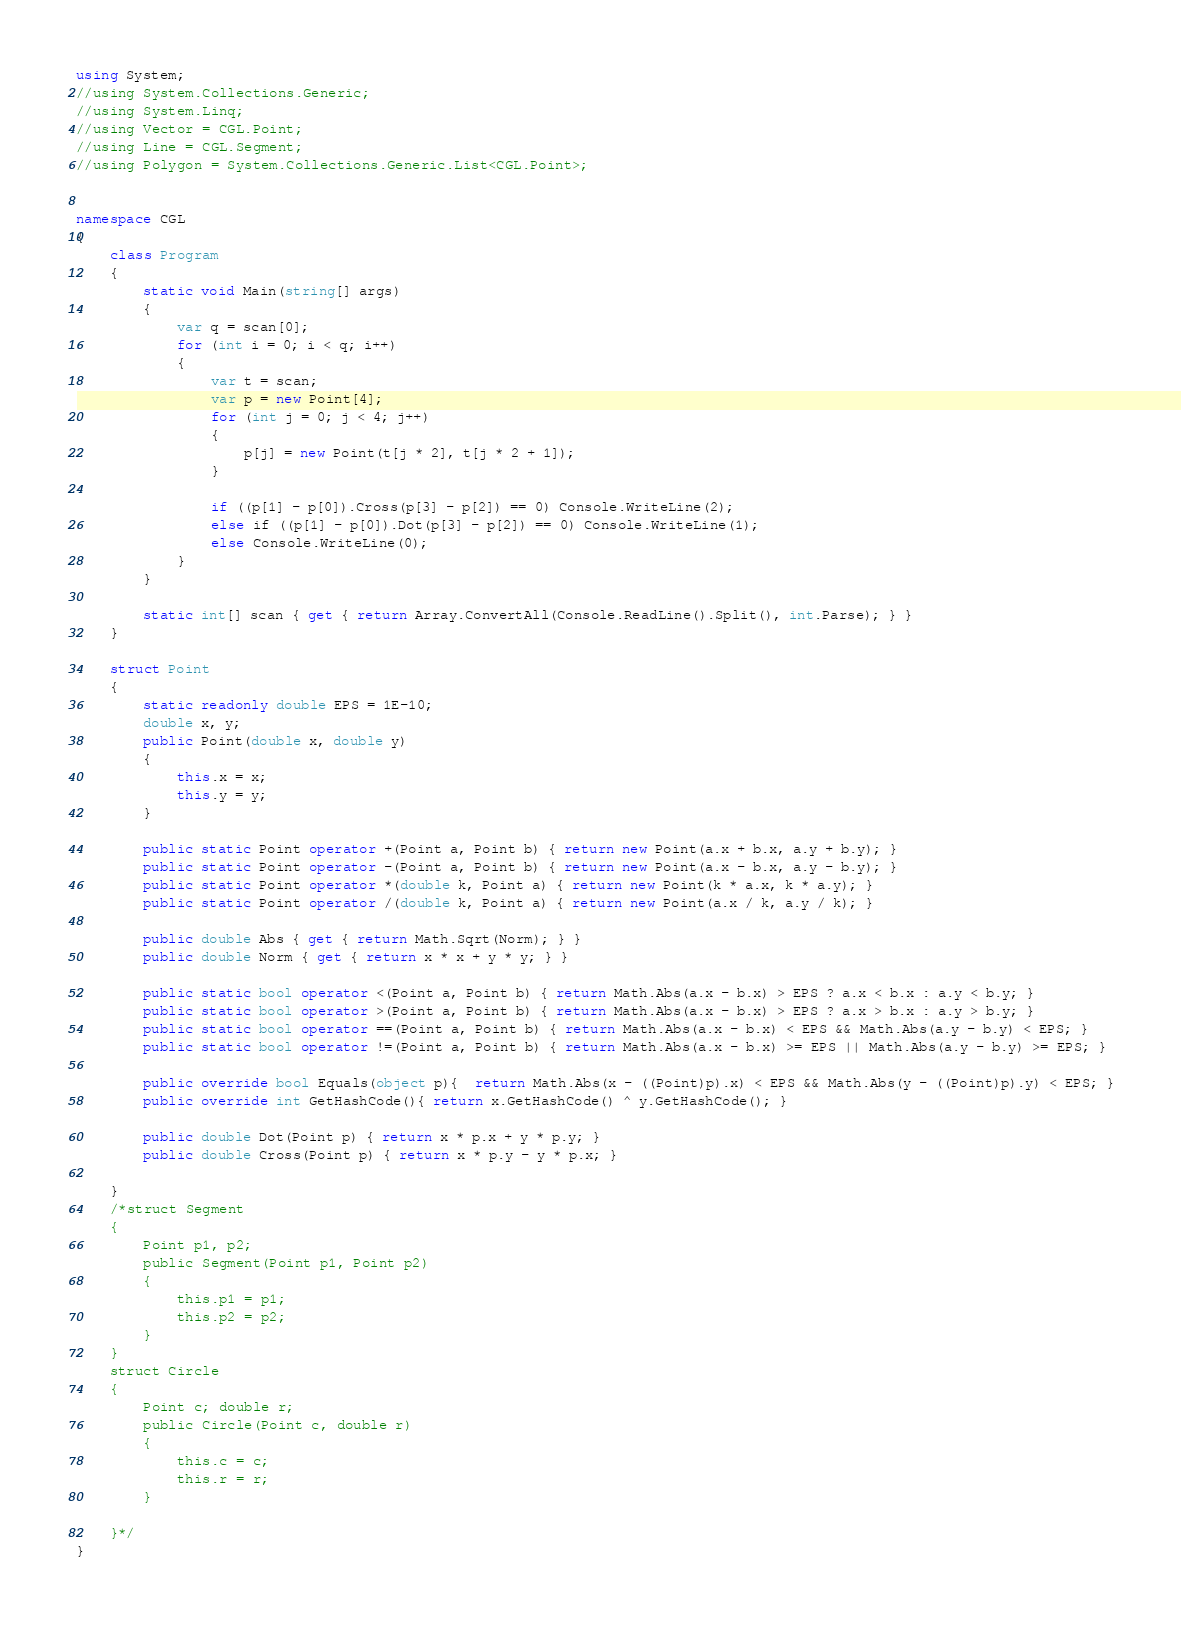<code> <loc_0><loc_0><loc_500><loc_500><_C#_>using System;
//using System.Collections.Generic;
//using System.Linq;
//using Vector = CGL.Point;
//using Line = CGL.Segment;
//using Polygon = System.Collections.Generic.List<CGL.Point>;


namespace CGL
{
    class Program
    {
        static void Main(string[] args)
        {
            var q = scan[0];
            for (int i = 0; i < q; i++)
            {
                var t = scan;
                var p = new Point[4];
                for (int j = 0; j < 4; j++)
                {
                    p[j] = new Point(t[j * 2], t[j * 2 + 1]);
                }

                if ((p[1] - p[0]).Cross(p[3] - p[2]) == 0) Console.WriteLine(2);
                else if ((p[1] - p[0]).Dot(p[3] - p[2]) == 0) Console.WriteLine(1);
                else Console.WriteLine(0);
            }
        }

        static int[] scan { get { return Array.ConvertAll(Console.ReadLine().Split(), int.Parse); } }
    }
    
    struct Point
    {
        static readonly double EPS = 1E-10;
        double x, y;
        public Point(double x, double y)
        {
            this.x = x;
            this.y = y;
        }

        public static Point operator +(Point a, Point b) { return new Point(a.x + b.x, a.y + b.y); }
        public static Point operator -(Point a, Point b) { return new Point(a.x - b.x, a.y - b.y); }
        public static Point operator *(double k, Point a) { return new Point(k * a.x, k * a.y); }
        public static Point operator /(double k, Point a) { return new Point(a.x / k, a.y / k); }
        
        public double Abs { get { return Math.Sqrt(Norm); } }  
        public double Norm { get { return x * x + y * y; } }

        public static bool operator <(Point a, Point b) { return Math.Abs(a.x - b.x) > EPS ? a.x < b.x : a.y < b.y; }
        public static bool operator >(Point a, Point b) { return Math.Abs(a.x - b.x) > EPS ? a.x > b.x : a.y > b.y; }
        public static bool operator ==(Point a, Point b) { return Math.Abs(a.x - b.x) < EPS && Math.Abs(a.y - b.y) < EPS; }
        public static bool operator !=(Point a, Point b) { return Math.Abs(a.x - b.x) >= EPS || Math.Abs(a.y - b.y) >= EPS; }

        public override bool Equals(object p){  return Math.Abs(x - ((Point)p).x) < EPS && Math.Abs(y - ((Point)p).y) < EPS; }
        public override int GetHashCode(){ return x.GetHashCode() ^ y.GetHashCode(); }

        public double Dot(Point p) { return x * p.x + y * p.y; }
        public double Cross(Point p) { return x * p.y - y * p.x; }

    }
    /*struct Segment
    {
        Point p1, p2;
        public Segment(Point p1, Point p2)
        {
            this.p1 = p1;
            this.p2 = p2;
        }
    }
    struct Circle
    {
        Point c; double r;
        public Circle(Point c, double r)
        {
            this.c = c;
            this.r = r;
        }

    }*/
}</code> 